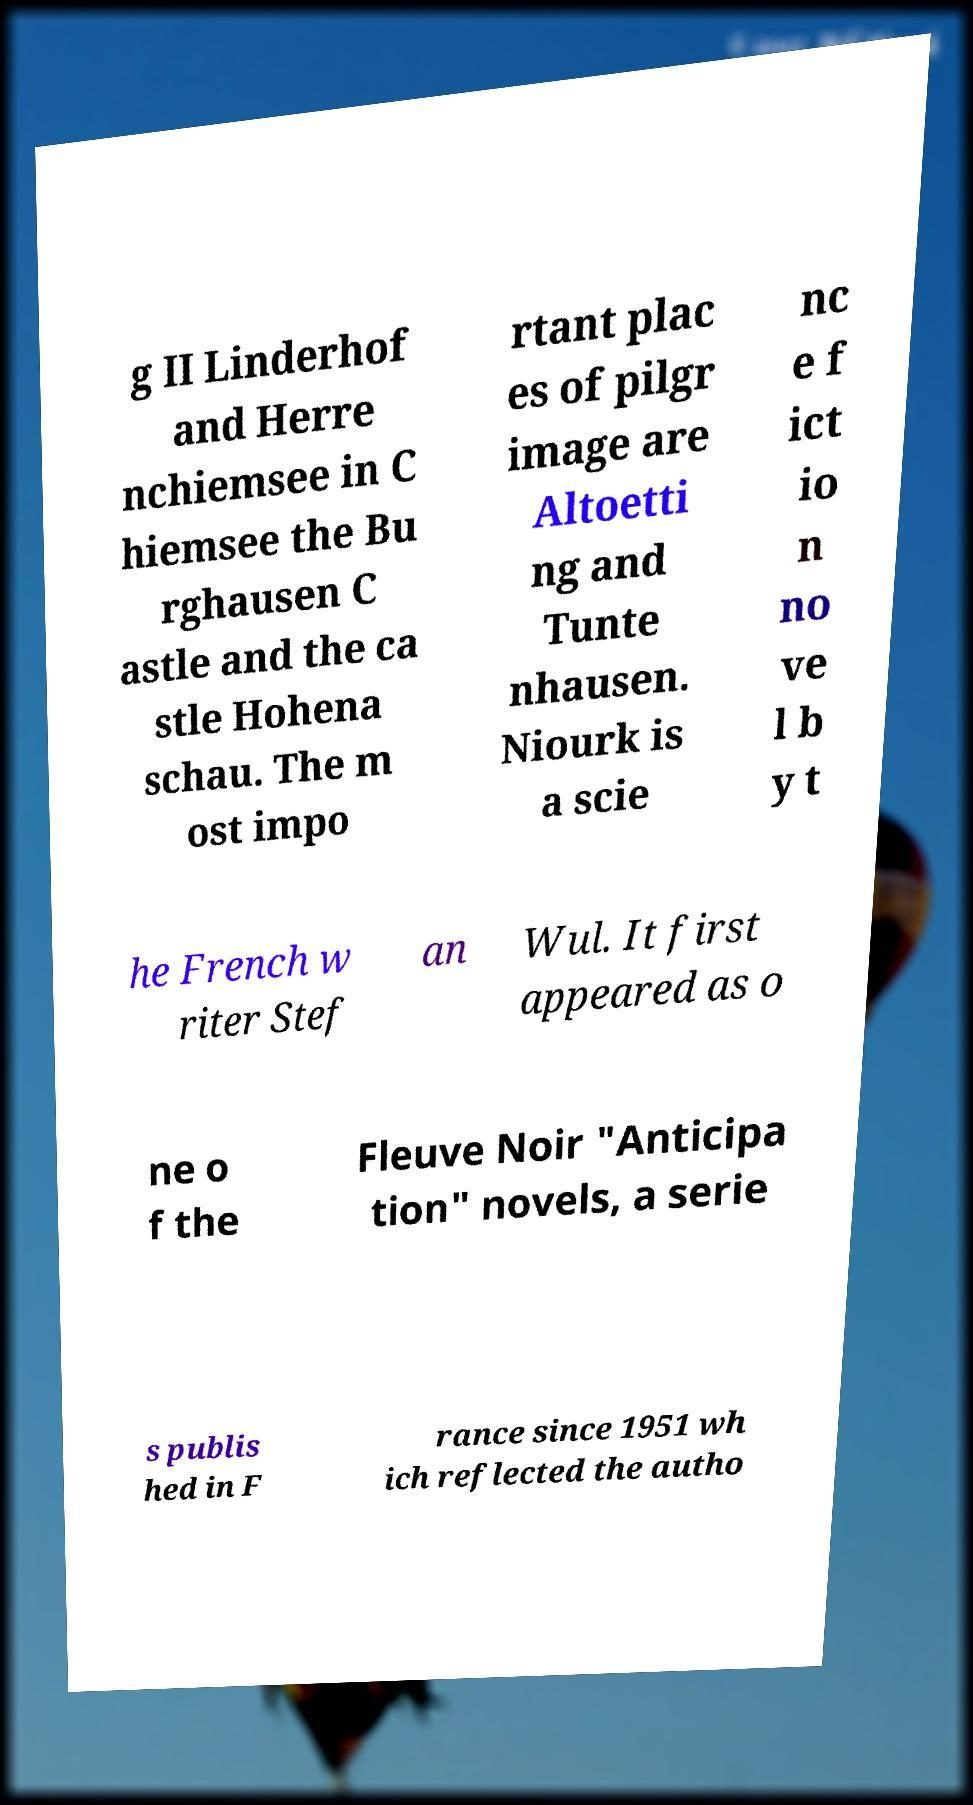I need the written content from this picture converted into text. Can you do that? g II Linderhof and Herre nchiemsee in C hiemsee the Bu rghausen C astle and the ca stle Hohena schau. The m ost impo rtant plac es of pilgr image are Altoetti ng and Tunte nhausen. Niourk is a scie nc e f ict io n no ve l b y t he French w riter Stef an Wul. It first appeared as o ne o f the Fleuve Noir "Anticipa tion" novels, a serie s publis hed in F rance since 1951 wh ich reflected the autho 